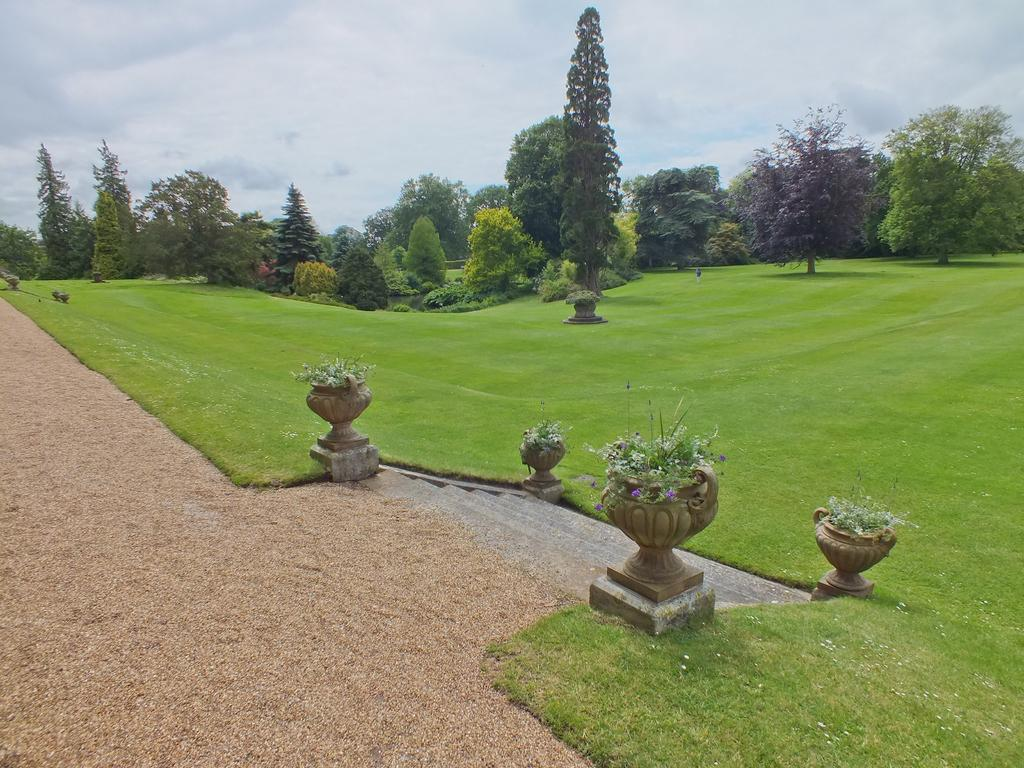What type of terrain is visible in the image? There is sand in the image. Are there any architectural features present in the image? Yes, there are stairs in the image. What type of vegetation can be seen in the image? There are potted plants and grass visible in the image. What can be seen in the background of the image? There are trees and the sky visible in the background of the image. How many men are holding pears in the image? There are no men or pears present in the image. 